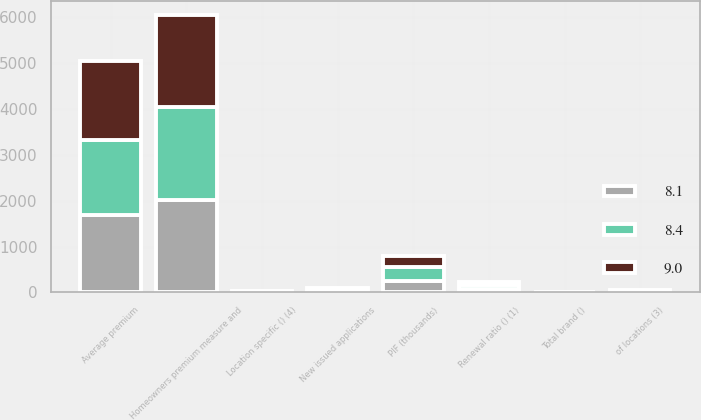Convert chart to OTSL. <chart><loc_0><loc_0><loc_500><loc_500><stacked_bar_chart><ecel><fcel>Homeowners premium measure and<fcel>PIF (thousands)<fcel>New issued applications<fcel>Average premium<fcel>Renewal ratio () (1)<fcel>of locations (3)<fcel>Total brand ()<fcel>Location specific () (4)<nl><fcel>9<fcel>2018<fcel>239<fcel>37<fcel>1724<fcel>80<fcel>20<fcel>4.7<fcel>8.1<nl><fcel>8.1<fcel>2017<fcel>254<fcel>30<fcel>1684<fcel>78.5<fcel>21<fcel>4.8<fcel>8.4<nl><fcel>8.4<fcel>2016<fcel>295<fcel>34<fcel>1639<fcel>79.8<fcel>19<fcel>5.1<fcel>9<nl></chart> 